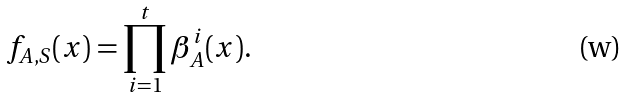<formula> <loc_0><loc_0><loc_500><loc_500>f _ { A , S } ( x ) = \prod _ { i = 1 } ^ { t } \beta _ { A } ^ { i } ( x ) .</formula> 